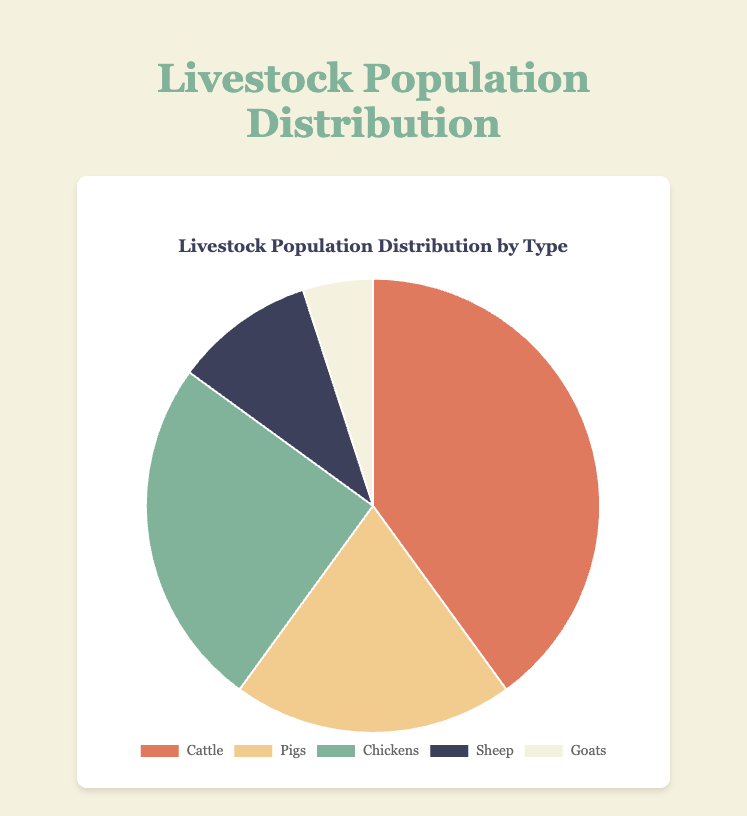Which livestock type has the largest population? The largest percentage value on the pie chart is for cattle, which is 40%.
Answer: Cattle Which color represents chickens? Chickens are represented by the third segment of the pie chart, which has a greenish color.
Answer: Green How much larger is the population of cattle compared to the population of goats? The population of cattle is 40% and the population of goats is 5%. The difference is 40% - 5% = 35%.
Answer: 35% What's the total population percentage of sheep and pigs combined? The population percentage for sheep is 10% and for pigs is 20%. The total combined population is 10% + 20% = 30%.
Answer: 30% Which livestock type has the smallest population? The smallest percentage value on the pie chart is for goats, which is 5%.
Answer: Goats What percentage of the livestock population is not cattle? The cattle population is 40%, so the population that is not cattle is 100% - 40% = 60%.
Answer: 60% How does the population of pigs compare to that of chickens? The population percentage for pigs is 20% and for chickens is 25%. Chickens have a larger population by 5%.
Answer: Chickens Which color represents the livestock type with the second largest population? The livestock type with the second largest population is chickens at 25%, represented by green.
Answer: Green What is the sum of the populations of the least two populous livestock types? The least two populous livestock types are goats (5%) and sheep (10%). The sum is 5% + 10% = 15%.
Answer: 15% How many types of livestock have a population percentage above 15%? The population percentages above 15% are cattle (40%), pigs (20%), and chickens (25%). There are three types.
Answer: Three 